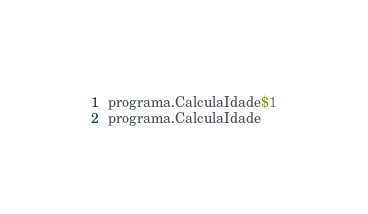Convert code to text. <code><loc_0><loc_0><loc_500><loc_500><_Rust_>programa.CalculaIdade$1
programa.CalculaIdade
</code> 